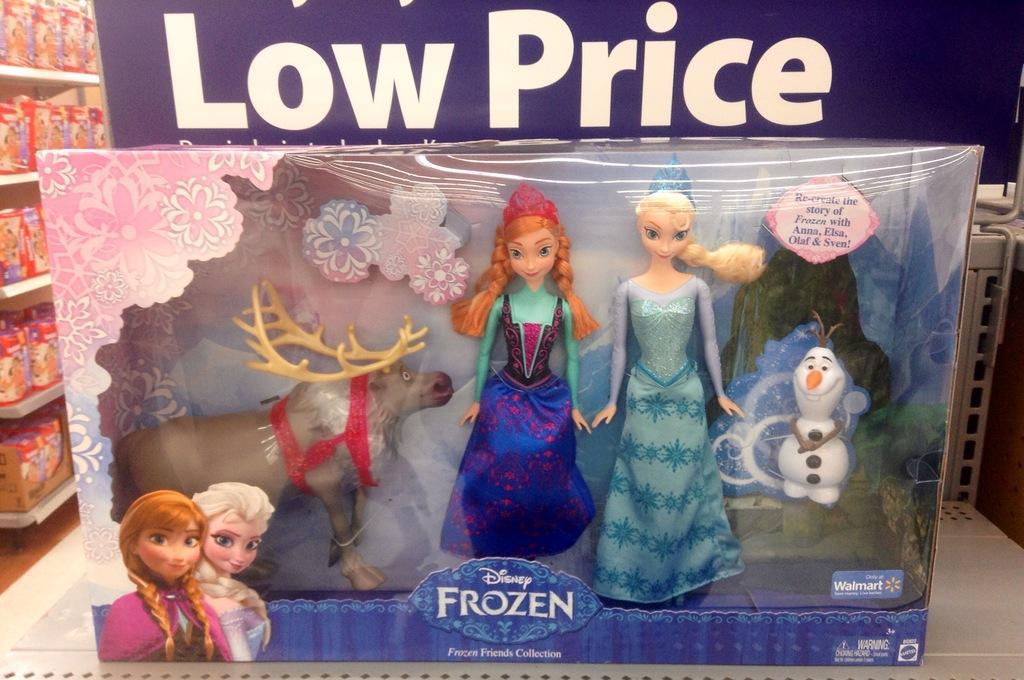In one or two sentences, can you explain what this image depicts? There are toys present in a box as we can see at the bottom of this image. There is a text board at the top of this image. We can see objects on the shelves which is on the left side of this image. 